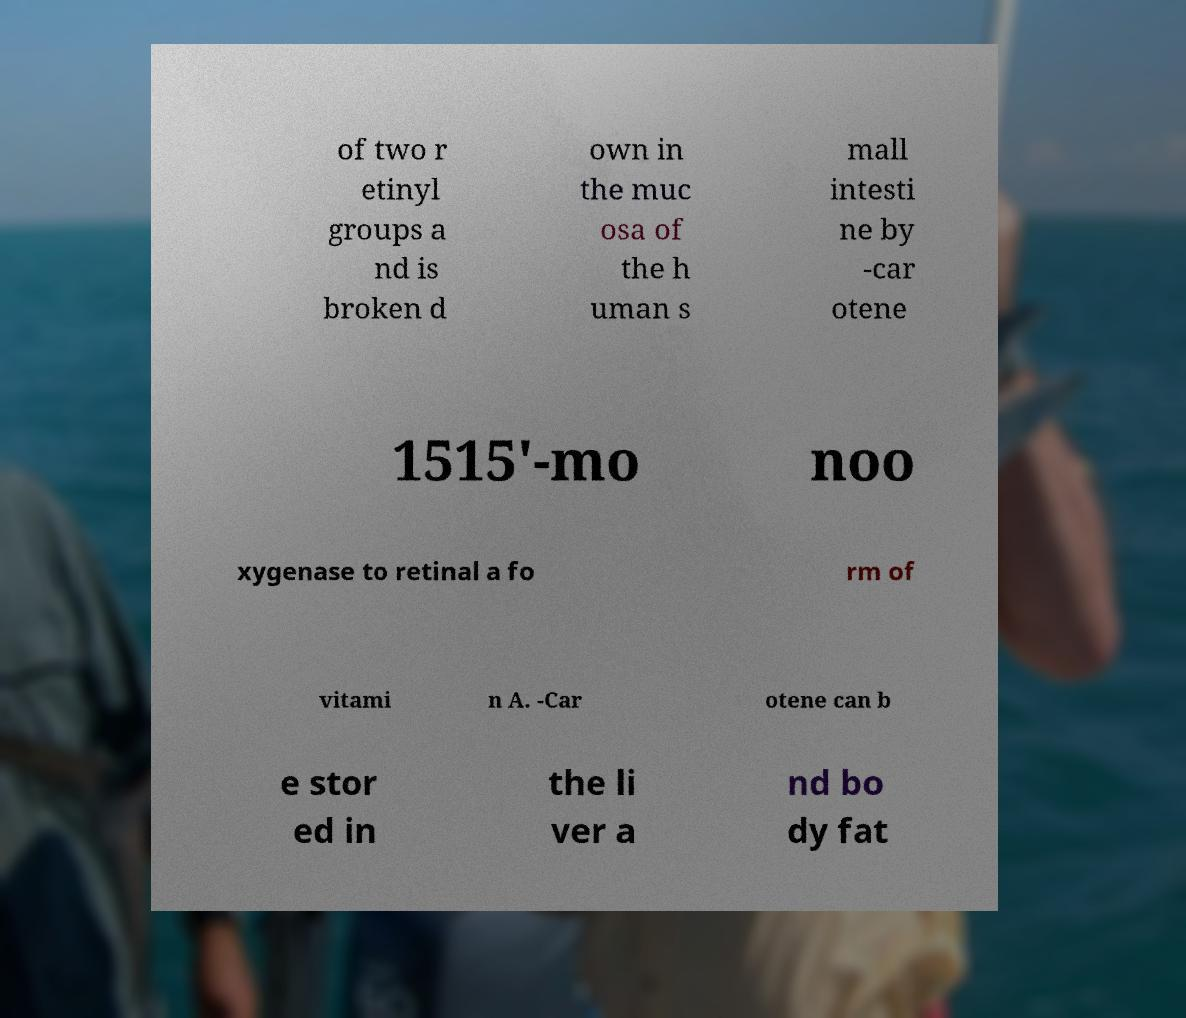I need the written content from this picture converted into text. Can you do that? of two r etinyl groups a nd is broken d own in the muc osa of the h uman s mall intesti ne by -car otene 1515'-mo noo xygenase to retinal a fo rm of vitami n A. -Car otene can b e stor ed in the li ver a nd bo dy fat 